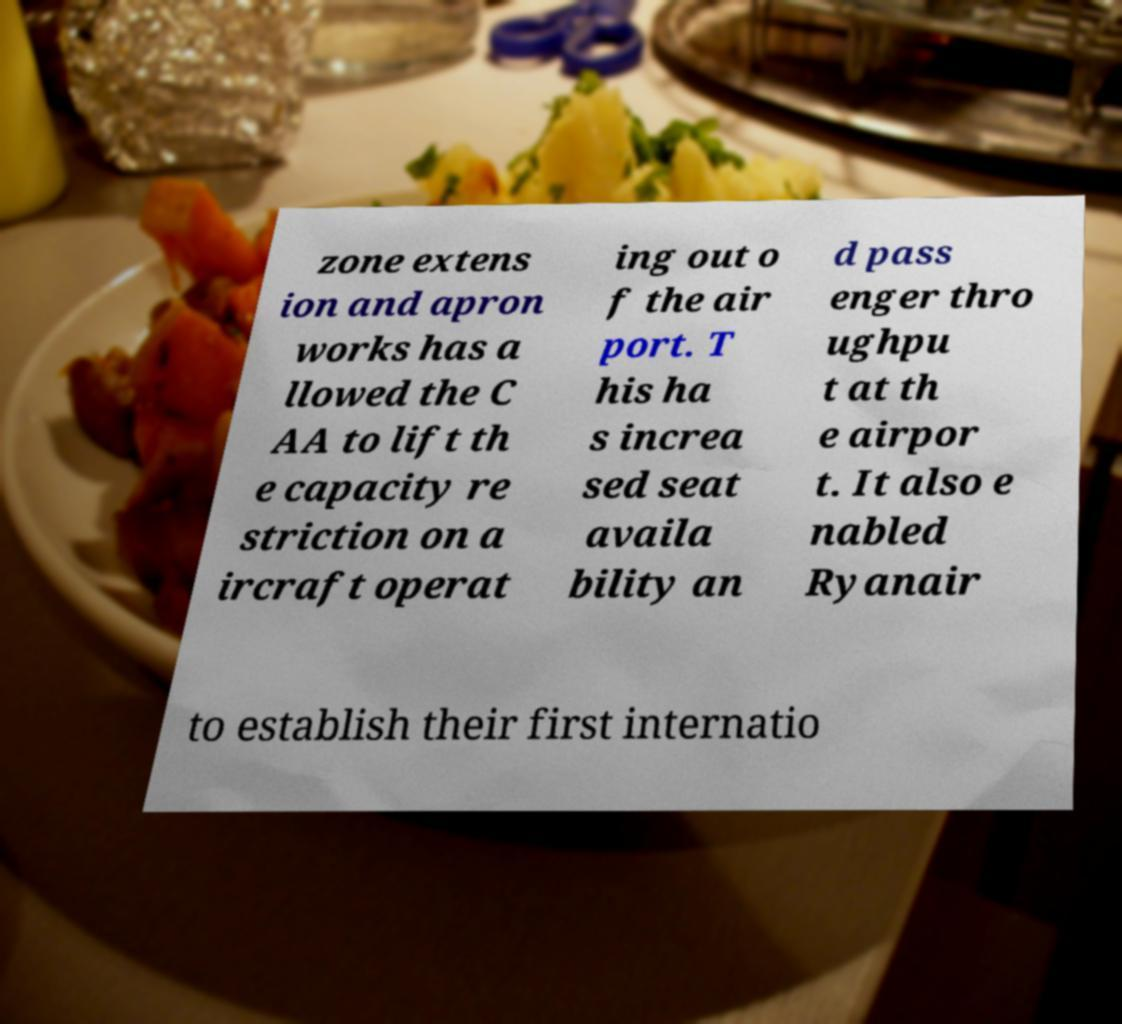Can you accurately transcribe the text from the provided image for me? zone extens ion and apron works has a llowed the C AA to lift th e capacity re striction on a ircraft operat ing out o f the air port. T his ha s increa sed seat availa bility an d pass enger thro ughpu t at th e airpor t. It also e nabled Ryanair to establish their first internatio 